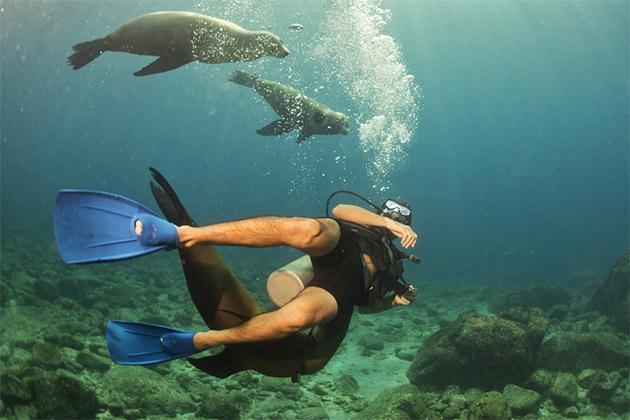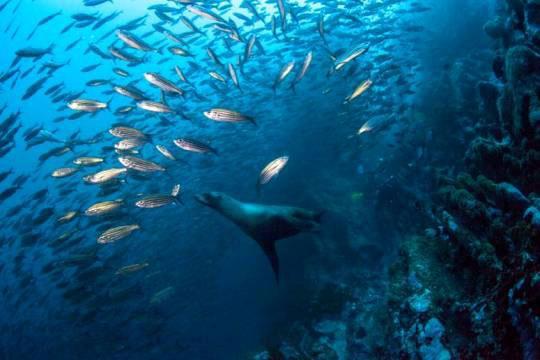The first image is the image on the left, the second image is the image on the right. For the images displayed, is the sentence "A person is swimming with the animals in the image on the left." factually correct? Answer yes or no. Yes. The first image is the image on the left, the second image is the image on the right. Analyze the images presented: Is the assertion "An image includes at least one human diver swimming in the vicinity of a seal." valid? Answer yes or no. Yes. 